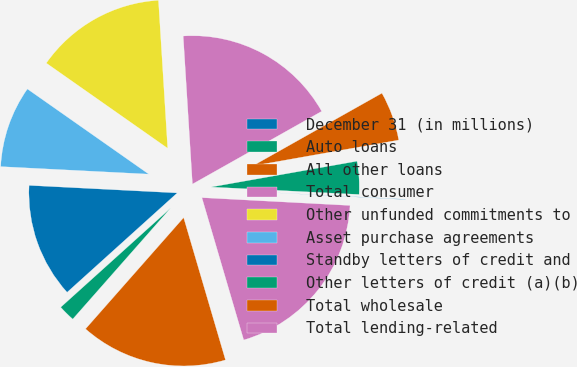Convert chart. <chart><loc_0><loc_0><loc_500><loc_500><pie_chart><fcel>December 31 (in millions)<fcel>Auto loans<fcel>All other loans<fcel>Total consumer<fcel>Other unfunded commitments to<fcel>Asset purchase agreements<fcel>Standby letters of credit and<fcel>Other letters of credit (a)(b)<fcel>Total wholesale<fcel>Total lending-related<nl><fcel>0.04%<fcel>3.59%<fcel>5.37%<fcel>17.83%<fcel>14.27%<fcel>8.93%<fcel>12.49%<fcel>1.82%<fcel>16.05%<fcel>19.61%<nl></chart> 